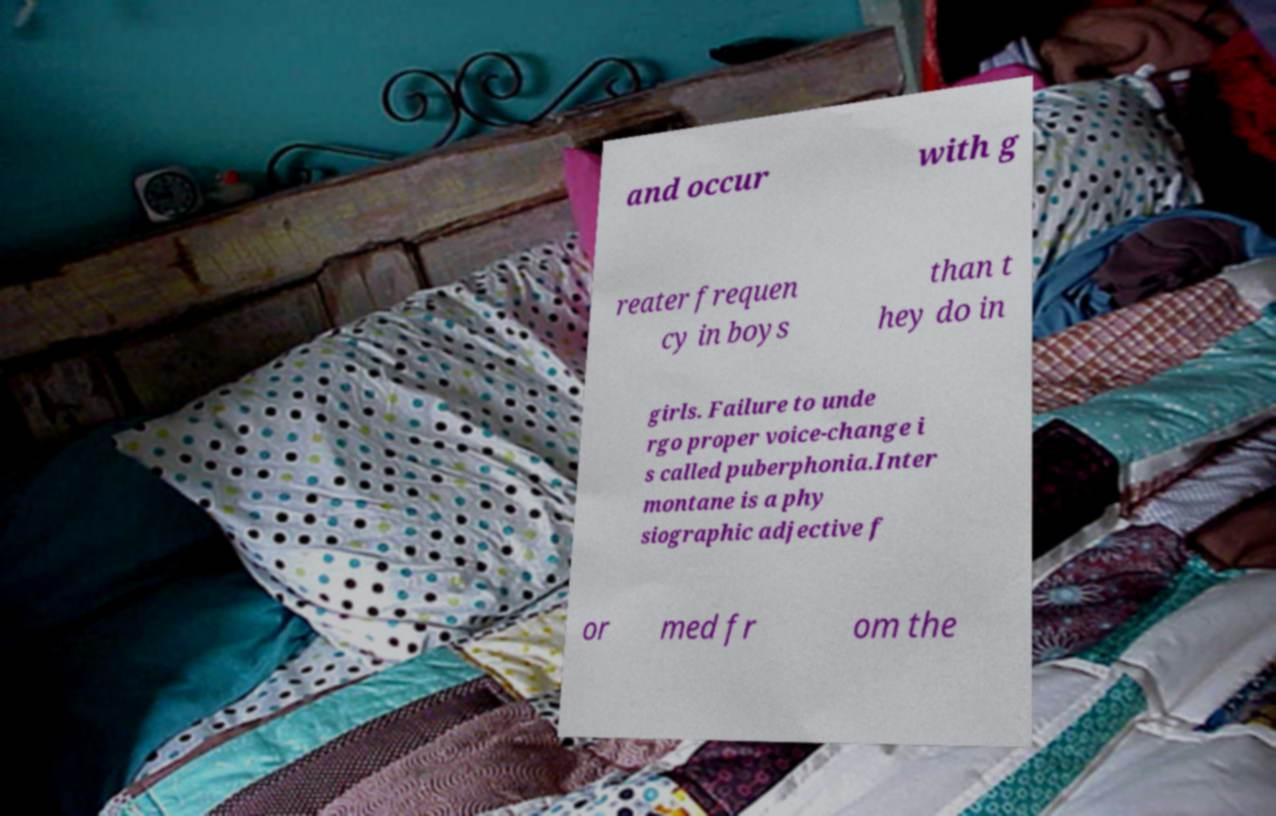Can you accurately transcribe the text from the provided image for me? and occur with g reater frequen cy in boys than t hey do in girls. Failure to unde rgo proper voice-change i s called puberphonia.Inter montane is a phy siographic adjective f or med fr om the 